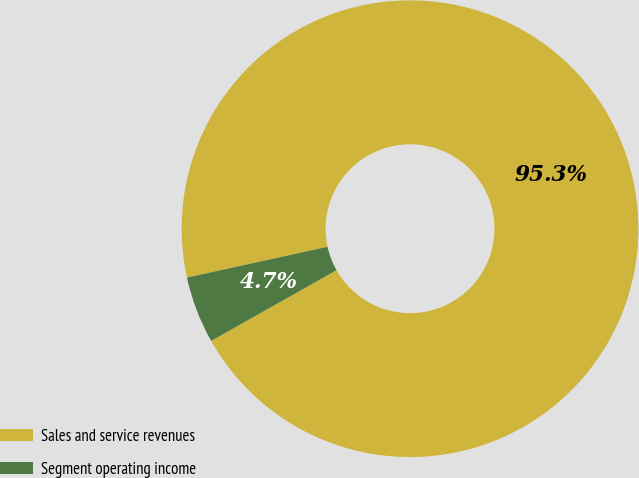Convert chart to OTSL. <chart><loc_0><loc_0><loc_500><loc_500><pie_chart><fcel>Sales and service revenues<fcel>Segment operating income<nl><fcel>95.26%<fcel>4.74%<nl></chart> 